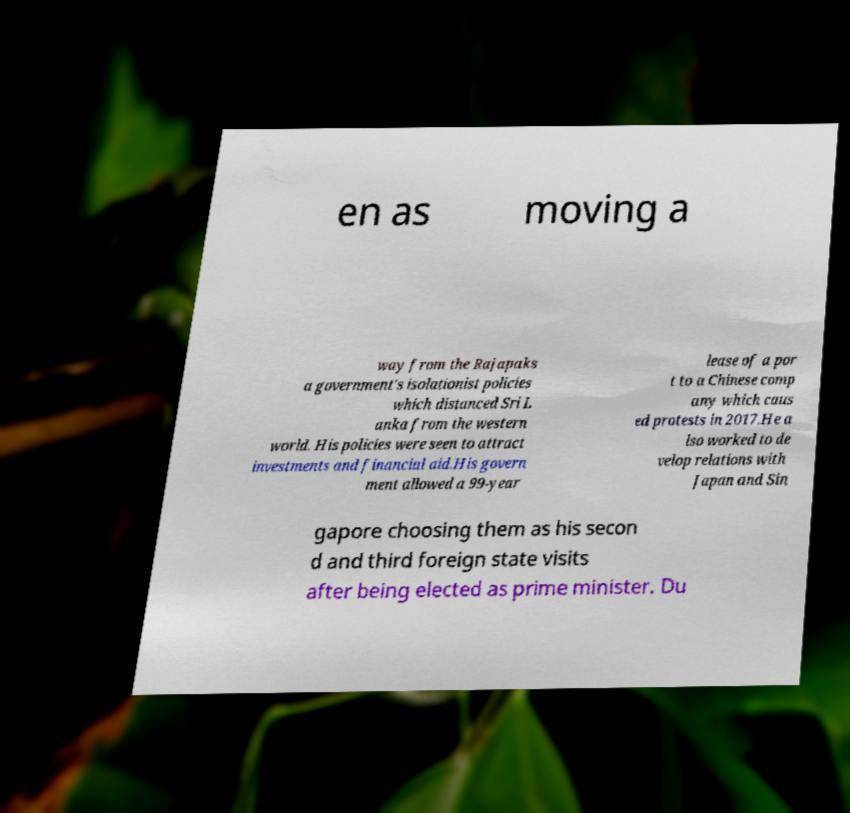I need the written content from this picture converted into text. Can you do that? en as moving a way from the Rajapaks a government's isolationist policies which distanced Sri L anka from the western world. His policies were seen to attract investments and financial aid.His govern ment allowed a 99-year lease of a por t to a Chinese comp any which caus ed protests in 2017.He a lso worked to de velop relations with Japan and Sin gapore choosing them as his secon d and third foreign state visits after being elected as prime minister. Du 